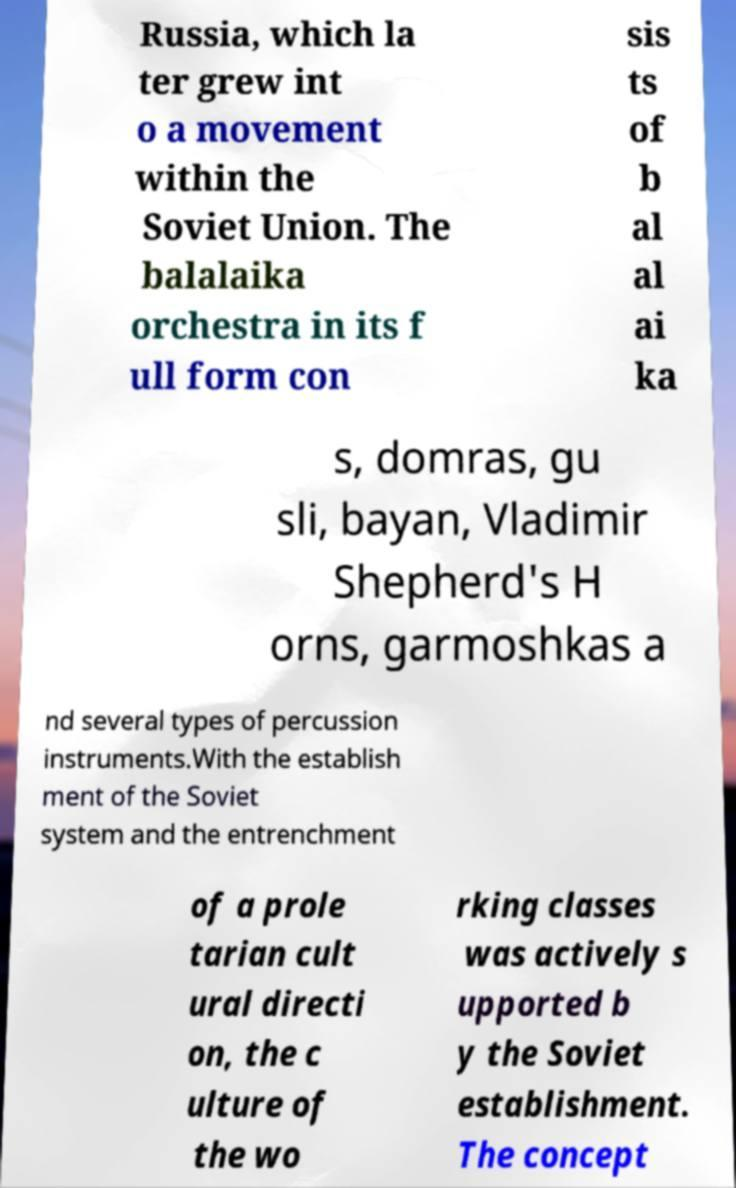There's text embedded in this image that I need extracted. Can you transcribe it verbatim? Russia, which la ter grew int o a movement within the Soviet Union. The balalaika orchestra in its f ull form con sis ts of b al al ai ka s, domras, gu sli, bayan, Vladimir Shepherd's H orns, garmoshkas a nd several types of percussion instruments.With the establish ment of the Soviet system and the entrenchment of a prole tarian cult ural directi on, the c ulture of the wo rking classes was actively s upported b y the Soviet establishment. The concept 